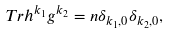<formula> <loc_0><loc_0><loc_500><loc_500>T r h ^ { k _ { 1 } } g ^ { k _ { 2 } } = n \delta _ { k _ { 1 } , 0 } \delta _ { k _ { 2 } , 0 } ,</formula> 